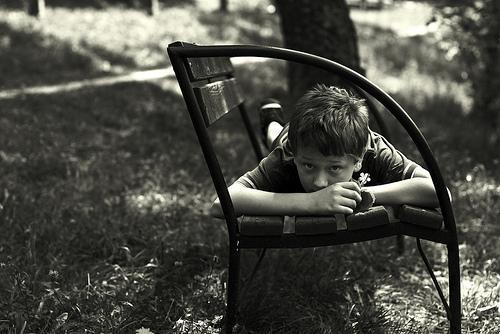How many people are in the picture?
Give a very brief answer. 1. 